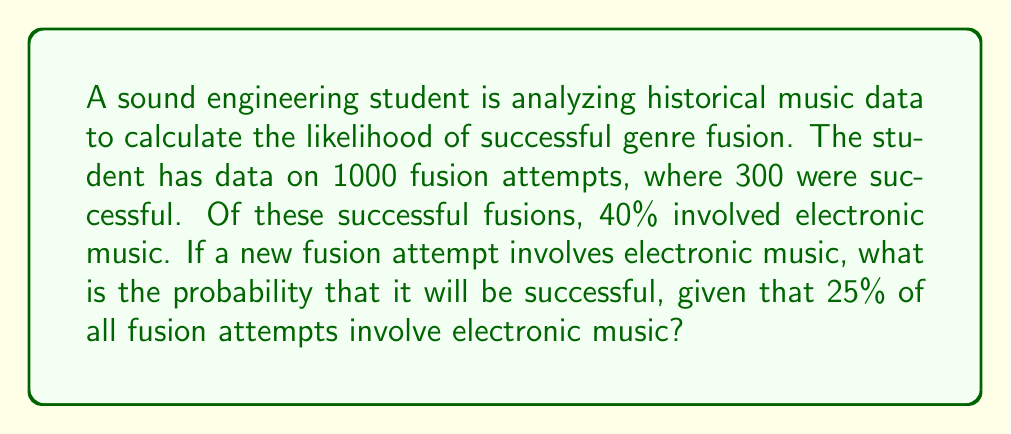Could you help me with this problem? Let's approach this step-by-step using Bayes' theorem:

1) Define events:
   S: Successful fusion
   E: Fusion involves electronic music

2) Given information:
   P(S) = 300/1000 = 0.3 (probability of success)
   P(E|S) = 0.4 (probability of electronic given success)
   P(E) = 0.25 (probability of electronic overall)

3) We want to find P(S|E) (probability of success given electronic)

4) Bayes' theorem states:

   $$P(S|E) = \frac{P(E|S) \cdot P(S)}{P(E)}$$

5) Plug in the values:

   $$P(S|E) = \frac{0.4 \cdot 0.3}{0.25}$$

6) Calculate:

   $$P(S|E) = \frac{0.12}{0.25} = 0.48$$

Therefore, the probability of a successful fusion given that it involves electronic music is 0.48 or 48%.
Answer: 0.48 